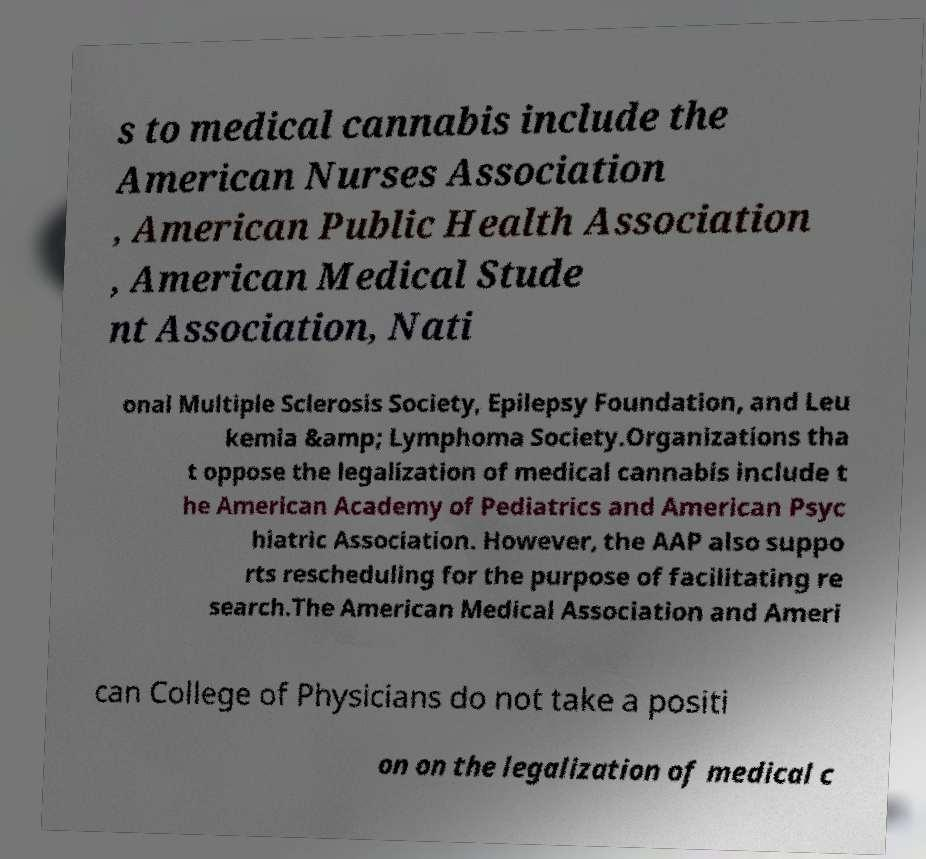For documentation purposes, I need the text within this image transcribed. Could you provide that? s to medical cannabis include the American Nurses Association , American Public Health Association , American Medical Stude nt Association, Nati onal Multiple Sclerosis Society, Epilepsy Foundation, and Leu kemia &amp; Lymphoma Society.Organizations tha t oppose the legalization of medical cannabis include t he American Academy of Pediatrics and American Psyc hiatric Association. However, the AAP also suppo rts rescheduling for the purpose of facilitating re search.The American Medical Association and Ameri can College of Physicians do not take a positi on on the legalization of medical c 